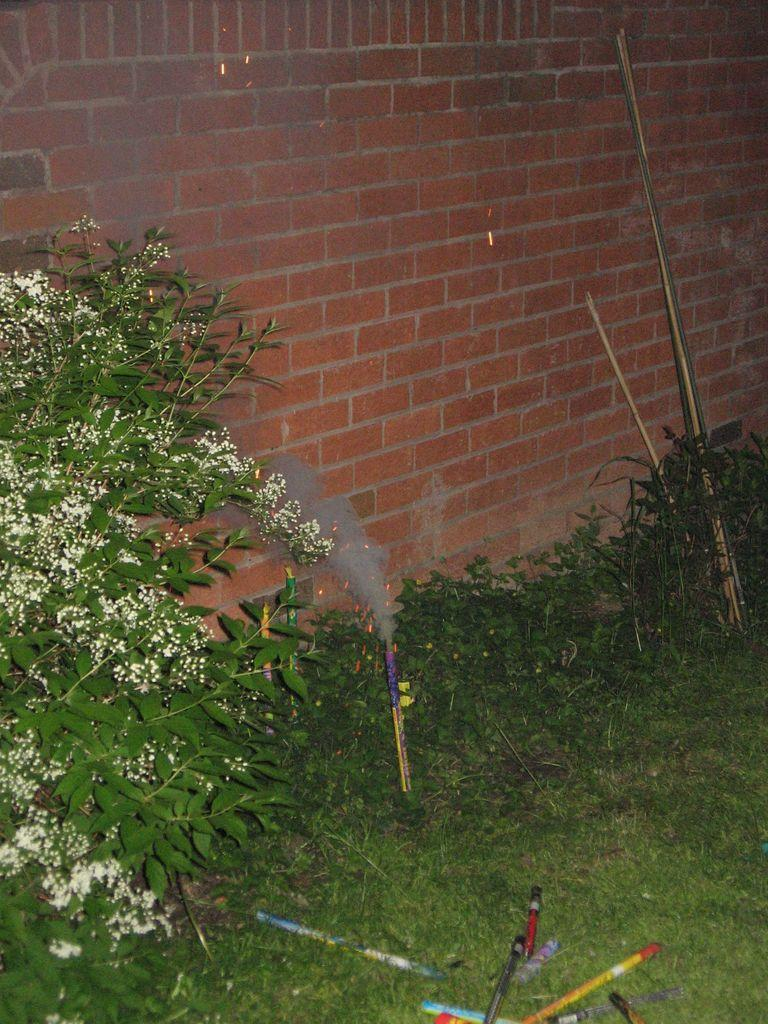What type of vegetation is present on the land in the image? There is grass on the land in the image. What else can be seen on the ground in the image? There are plants on the ground in the image. What is the nature of the smoke visible in the image? The smoke is visible in the image, but its source or nature is not specified. What color is the wall in the background of the image? There is a red color wall in the background of the image. How does the cork affect the plants in the image? There is no cork present in the image, so it cannot affect the plants. What is the change in the weather that caused the smoke in the image? The facts provided do not specify the cause of the smoke or any change in the weather. 